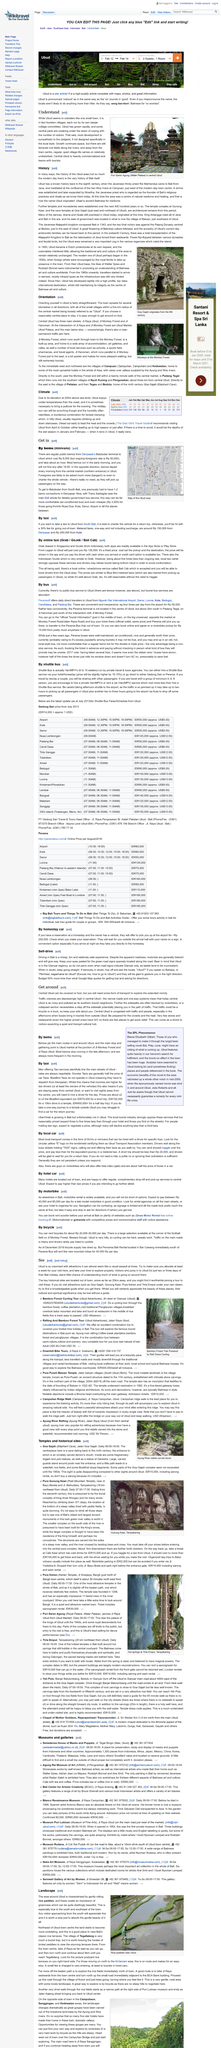Point out several critical features in this image. Most bemos from Denpasar's Batubulan terminal to Ubud run in the early morning. In total, there are 14 villages that are governed by their own banjar. In Bali, the availability of air conditioning is limited, with only a few stores and restaurants, even the higher priced ones, having A/C. Yes, public bemos are one of the ways to access the area depicted on the map. Driving in Bali is an enjoyable and budget-friendly experience, as it is considered to be relatively safe and a great way to explore the island. 